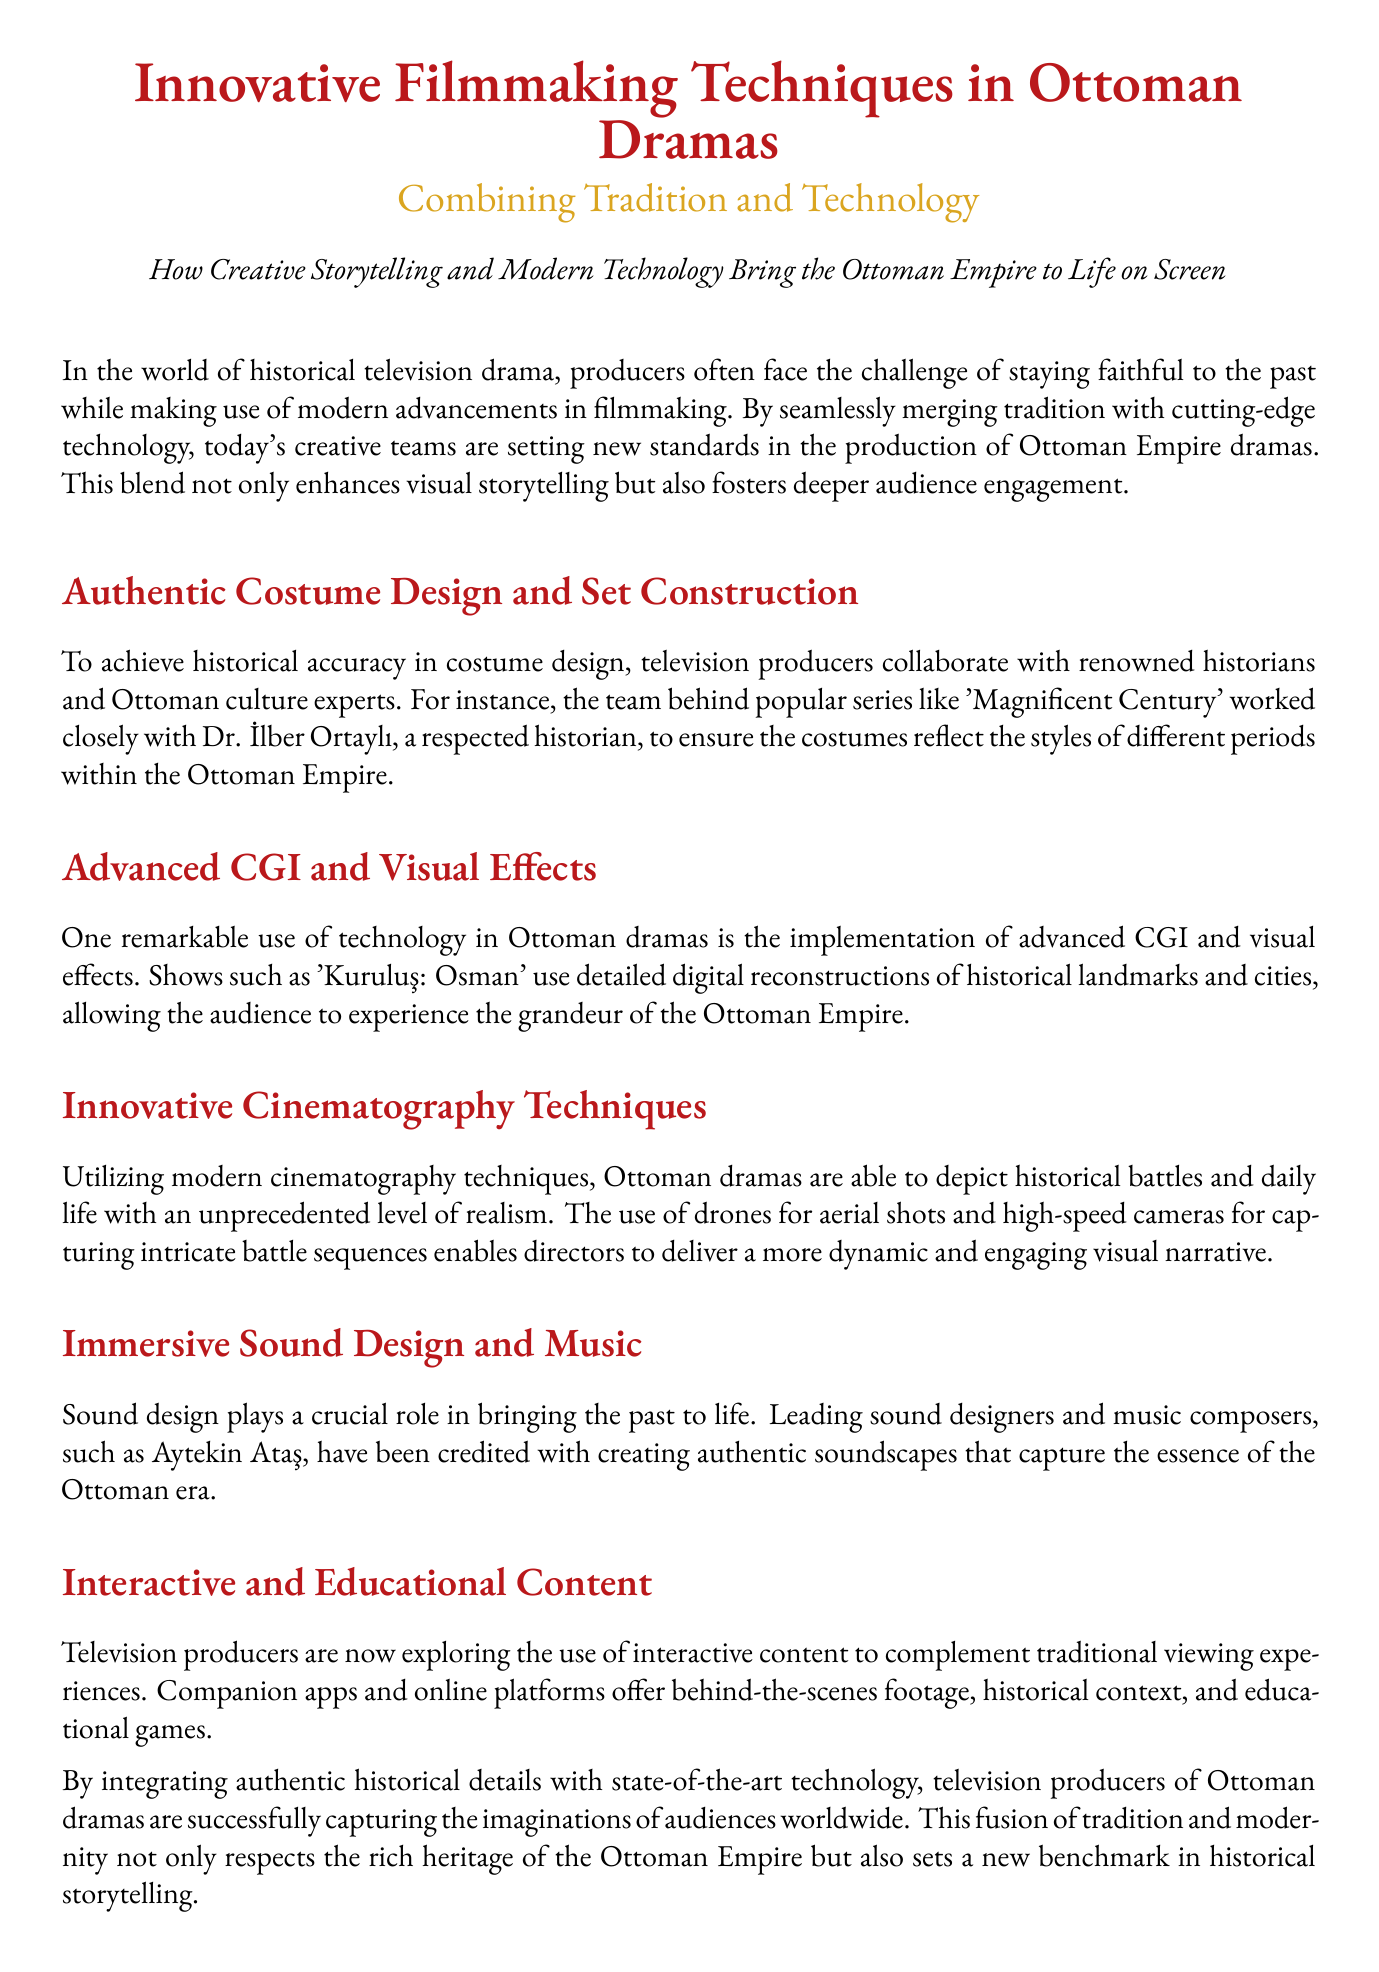What is the main theme of the document? The main theme is about combining tradition with technology in filmmaking for Ottoman dramas.
Answer: Combining Tradition and Technology Who collaborated with the producers of 'Magnificent Century'? The document states that they collaborated with Dr. İlber Ortaylı, a historian.
Answer: Dr. İlber Ortaylı What technology is used for aerial shots in Ottoman dramas? Drones are mentioned as the technology used for aerial shots.
Answer: Drones Name one show that uses advanced CGI and visual effects. 'Kuruluş: Osman' is mentioned as a show using these techniques.
Answer: 'Kuruluş: Osman' What role does sound design play in historical dramas? The document highlights that sound design brings the past to life.
Answer: Bringing the past to life What type of interactive content are producers exploring? Producers are exploring companion apps and online platforms.
Answer: Companion apps and online platforms What are producers aiming to achieve by integrating technology and tradition? The aim is to successfully capture the imaginations of audiences worldwide.
Answer: Capture the imaginations of audiences worldwide What visual storytelling aspect is enhanced by modern cinematography techniques? The realism of historical battles and daily life is enhanced.
Answer: Realism of historical battles and daily life 